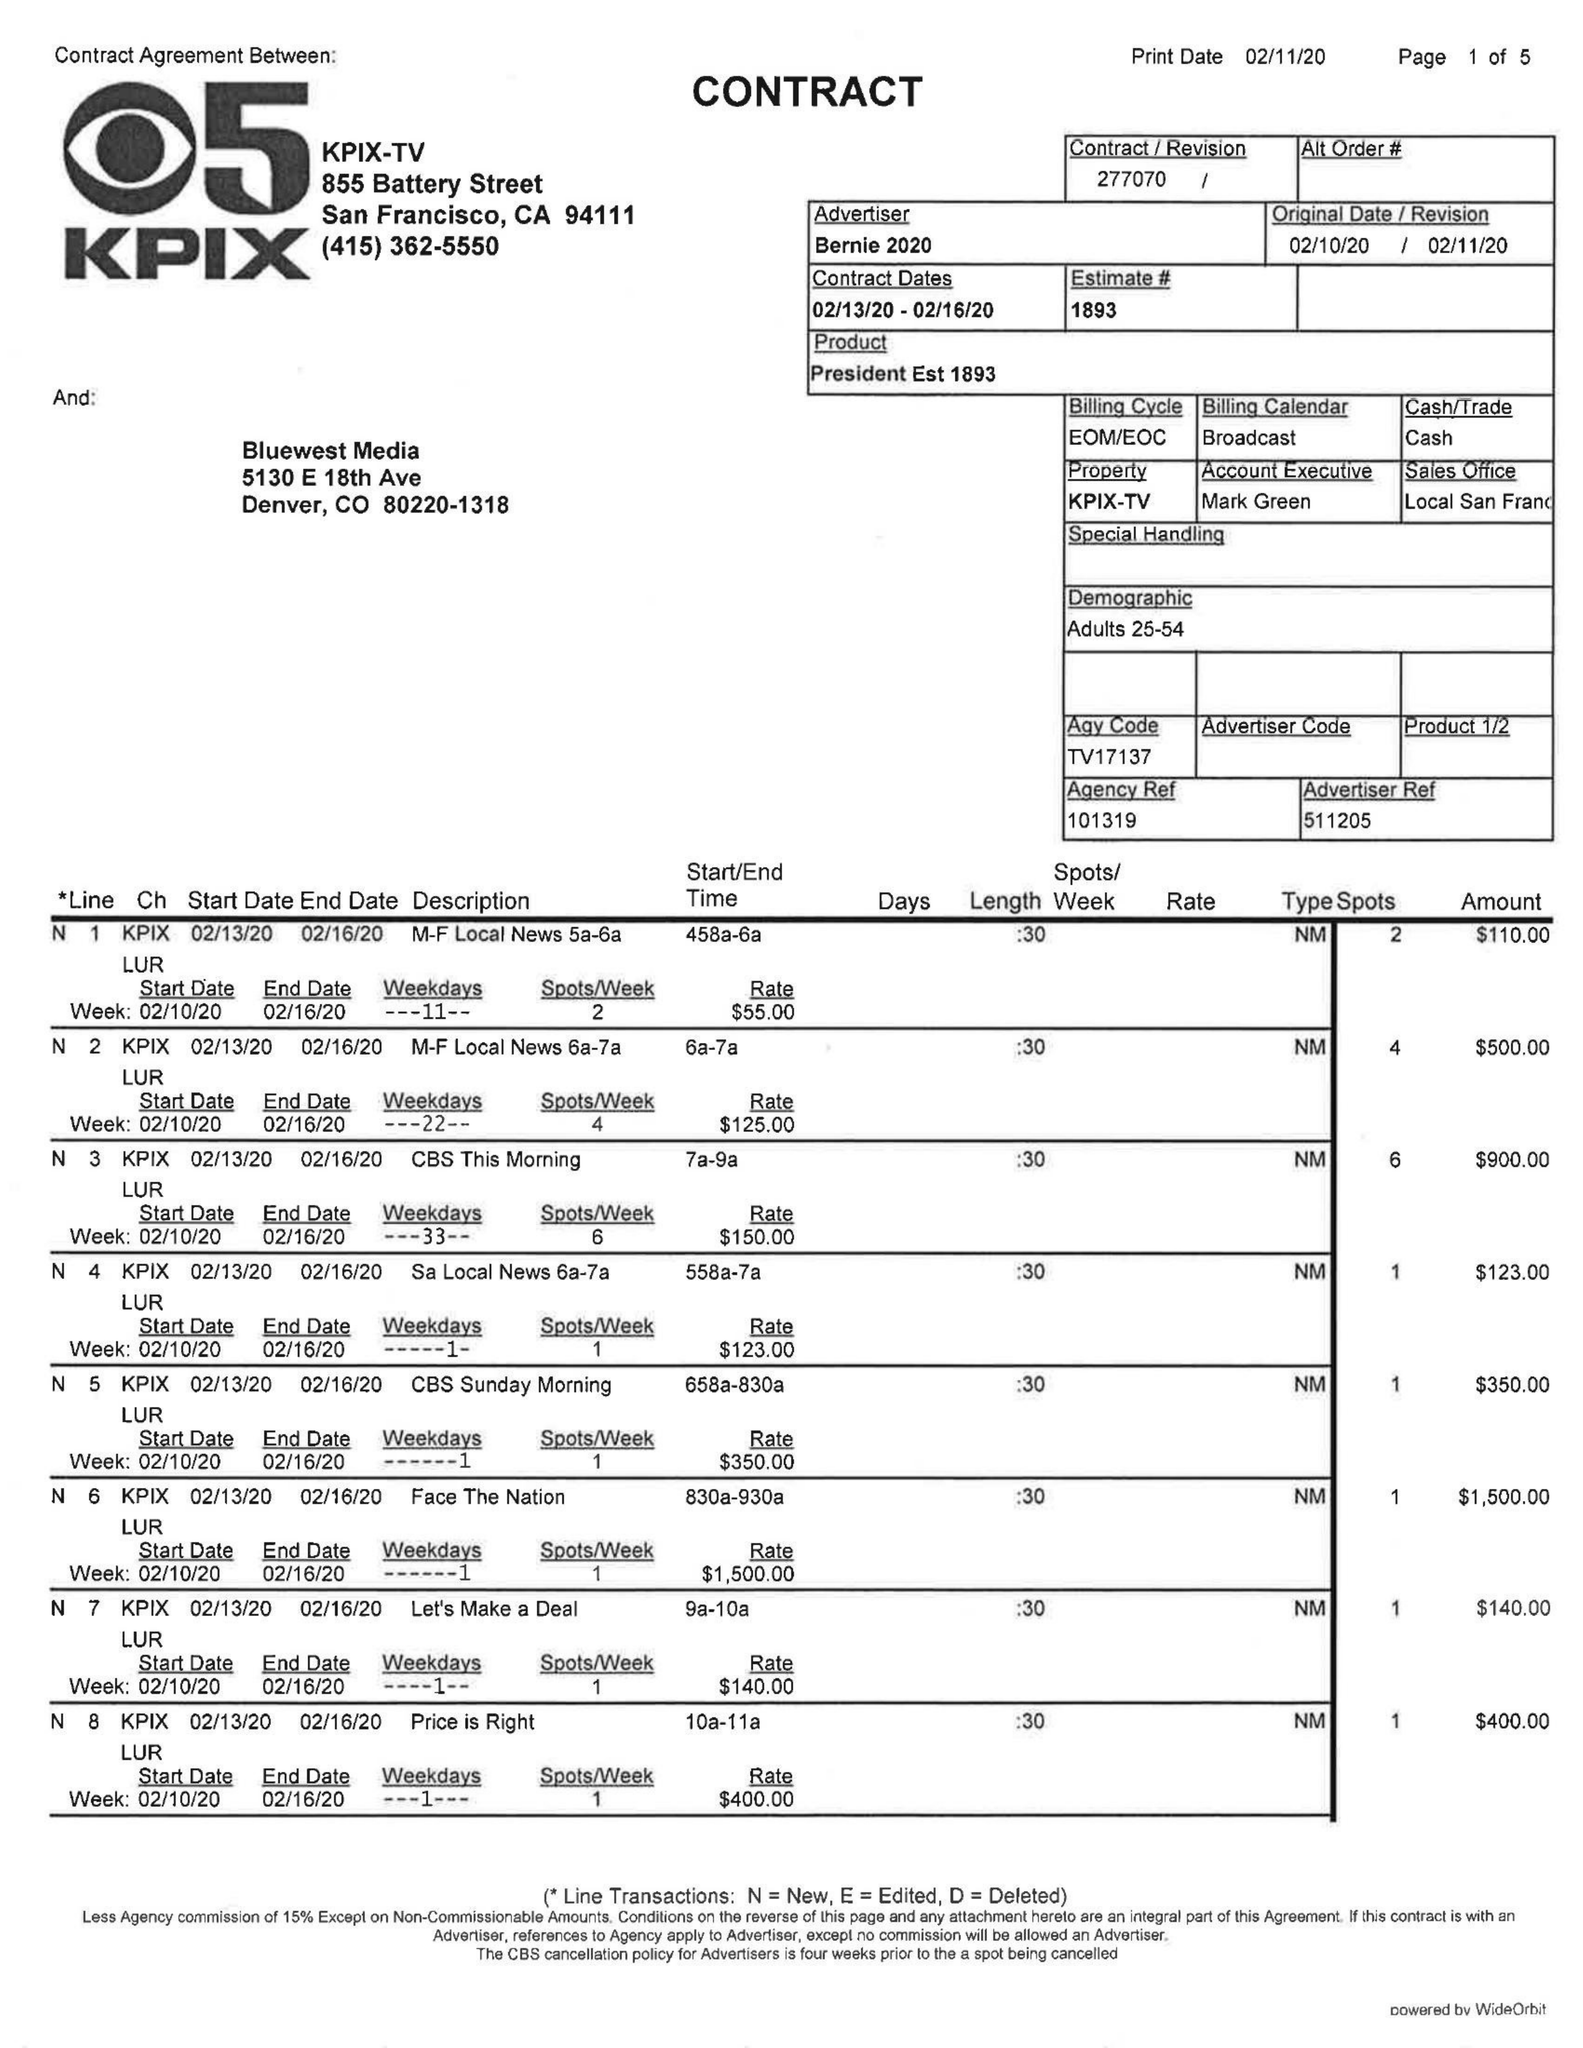What is the value for the gross_amount?
Answer the question using a single word or phrase. 25741.00 